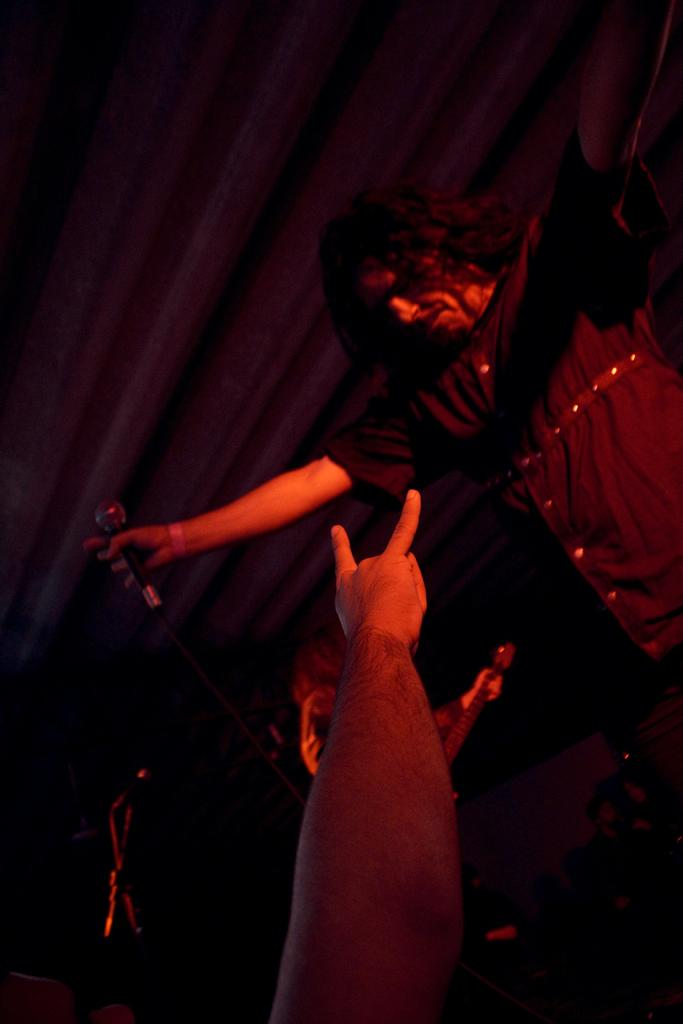Who is the main subject in the image? There is a person at the bottom of the image. What is the person at the bottom of the image doing? The person is showing fingers. Can you describe the second person in the image? The second person is beside the first person and is holding a mic with one hand. What is the color of the background in the image? The background of the image is dark in color. What country is depicted in the background of the image? There is no country depicted in the background of the image; it is a dark color without any specific geographical features. Can you tell me how many railway tracks are visible in the image? There are no railway tracks present in the image. 